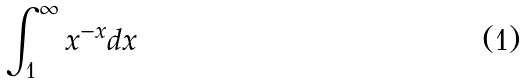<formula> <loc_0><loc_0><loc_500><loc_500>\int _ { 1 } ^ { \infty } x ^ { - x } d x</formula> 